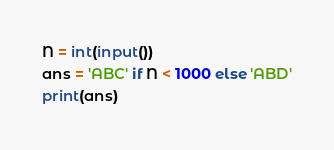Convert code to text. <code><loc_0><loc_0><loc_500><loc_500><_Python_>N = int(input())
ans = 'ABC' if N < 1000 else 'ABD'
print(ans)
</code> 